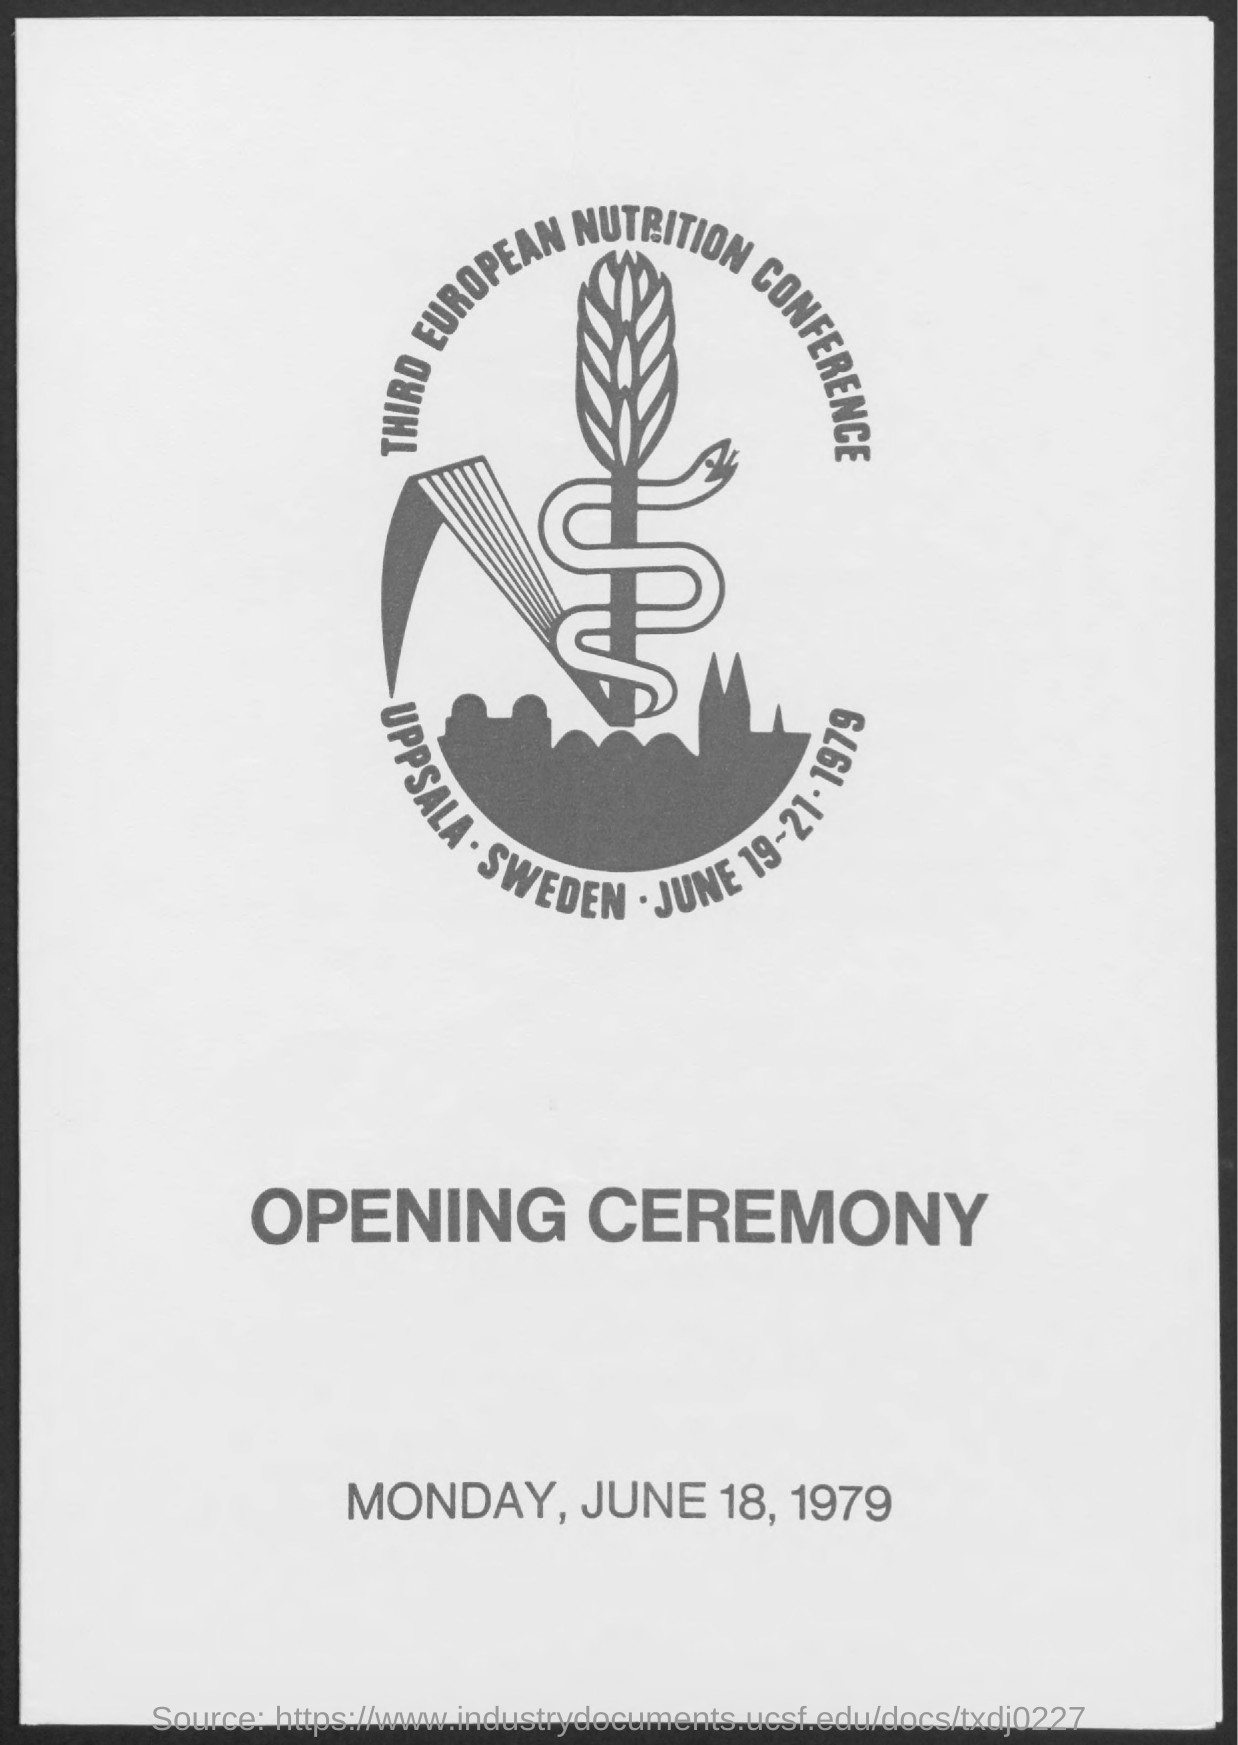List a handful of essential elements in this visual. The opening ceremony of the Third European Nutrition Conference took place on Monday, June 18, 1979. 